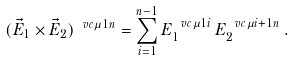Convert formula to latex. <formula><loc_0><loc_0><loc_500><loc_500>( \vec { E } _ { 1 } \times \vec { E } _ { 2 } ) ^ { \ v c \mu 1 n } = \sum ^ { n - 1 } _ { i = 1 } E _ { 1 } ^ { \ v c \mu 1 i } \, E _ { 2 } ^ { \ v c \mu { i + 1 } n } \, .</formula> 